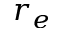Convert formula to latex. <formula><loc_0><loc_0><loc_500><loc_500>r _ { e }</formula> 